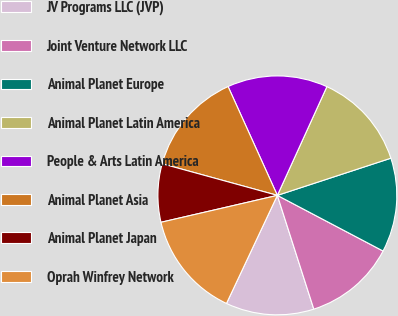Convert chart. <chart><loc_0><loc_0><loc_500><loc_500><pie_chart><fcel>JV Programs LLC (JVP)<fcel>Joint Venture Network LLC<fcel>Animal Planet Europe<fcel>Animal Planet Latin America<fcel>People & Arts Latin America<fcel>Animal Planet Asia<fcel>Animal Planet Japan<fcel>Oprah Winfrey Network<nl><fcel>11.94%<fcel>12.35%<fcel>12.75%<fcel>13.16%<fcel>13.57%<fcel>13.97%<fcel>7.88%<fcel>14.38%<nl></chart> 